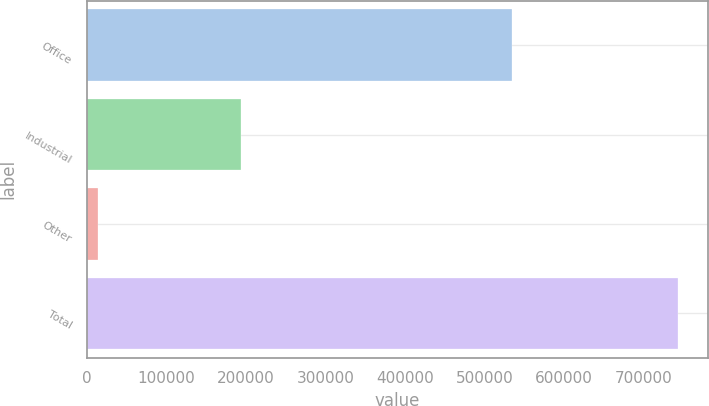Convert chart to OTSL. <chart><loc_0><loc_0><loc_500><loc_500><bar_chart><fcel>Office<fcel>Industrial<fcel>Other<fcel>Total<nl><fcel>534369<fcel>194670<fcel>14509<fcel>743548<nl></chart> 